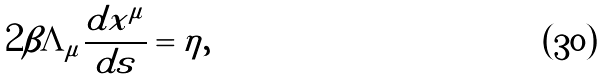<formula> <loc_0><loc_0><loc_500><loc_500>2 \beta \Lambda _ { \mu } \frac { d x ^ { \mu } } { d s } = \eta ,</formula> 